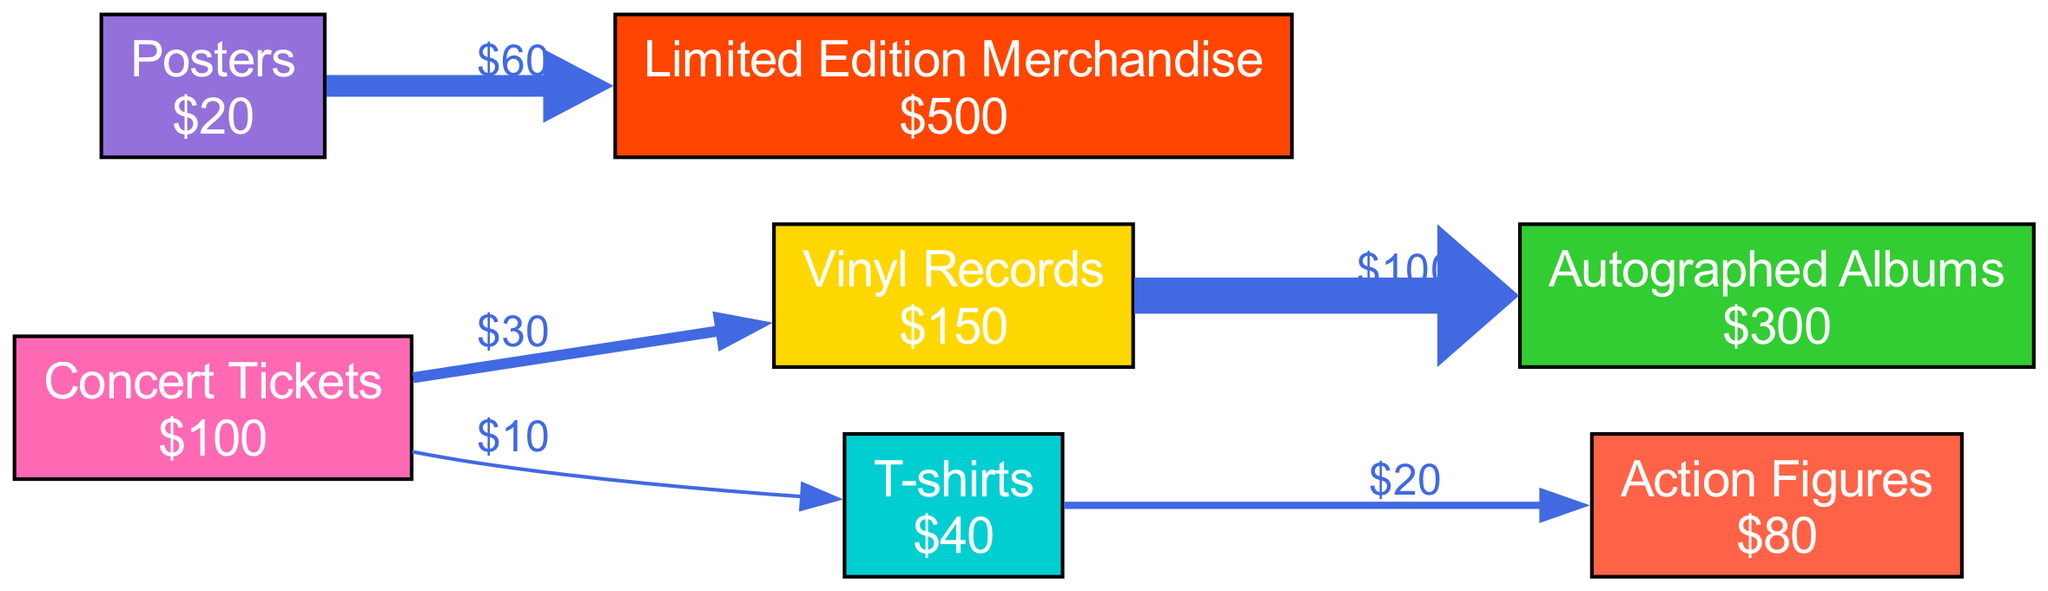What is the market value of the Autographed Albums? The diagram indicates that the Autographed Albums node has a value of $300, which is displayed directly next to the node.
Answer: $300 How many total nodes are in the diagram? By counting the nodes listed in the data, there are 7 total nodes shown in the diagram.
Answer: 7 What is the value of the link between Vinyl Records and Autographed Albums? The link connecting Vinyl Records to Autographed Albums shows a value of $100, which is labeled on the edge in the diagram.
Answer: $100 Which merchandise type has the highest market value? Upon examining the nodes, Limited Edition Merchandise has the highest value at $500, as displayed in the diagram.
Answer: Limited Edition Merchandise How much value is transferred from Concert Tickets to T-shirts? The flow from Concert Tickets to T-shirts shows a transfer of $10, which is represented along the edge between these two nodes.
Answer: $10 What is the cumulative value of items flowing from Concert Tickets? Adding the values of the flows from Concert Tickets, $30 (to Vinyl Records) and $10 (to T-shirts), gives a cumulative total of $40.
Answer: $40 Which type of merchandise leads to the most substantial link value? The link from Vinyl Records to Autographed Albums has a link value of $100, which is the highest among the connections depicted in the diagram.
Answer: Vinyl Records What is the total value of the items that flow from Posters? The only flow from Posters is $60 to Limited Edition Merchandise, which totals directly to that amount, as seen on the edge.
Answer: $60 